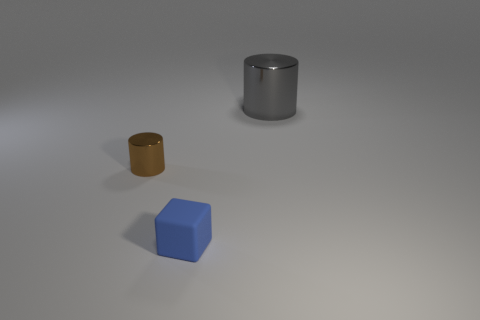Add 1 cyan objects. How many objects exist? 4 Subtract all cylinders. How many objects are left? 1 Add 2 green matte cylinders. How many green matte cylinders exist? 2 Subtract 0 red spheres. How many objects are left? 3 Subtract all metallic cylinders. Subtract all small shiny objects. How many objects are left? 0 Add 2 small brown shiny objects. How many small brown shiny objects are left? 3 